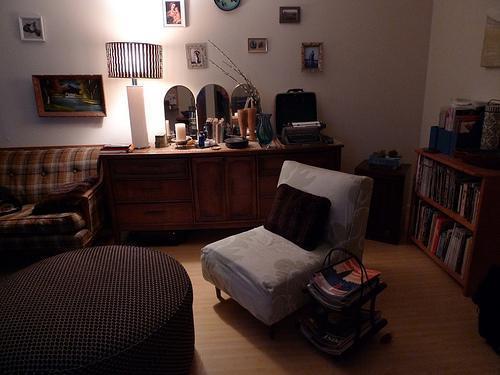How many chairs are in the photo?
Give a very brief answer. 1. 